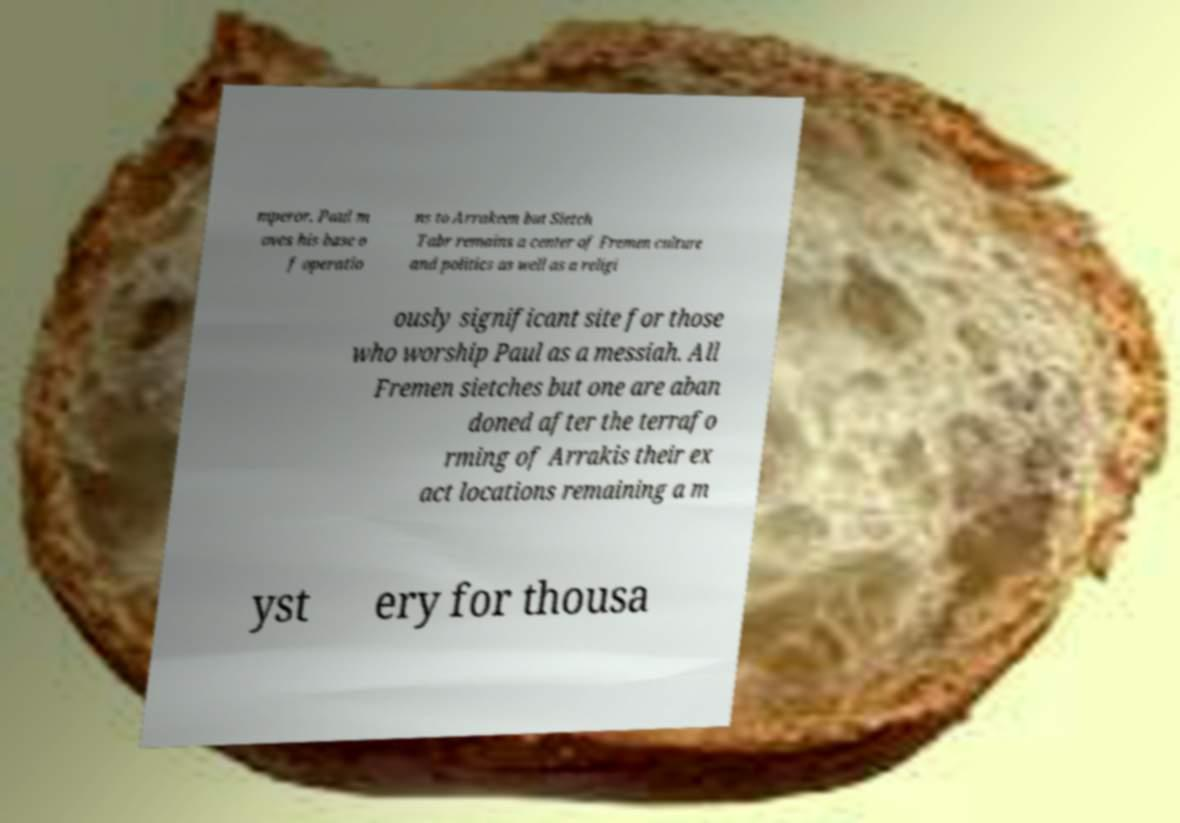Could you assist in decoding the text presented in this image and type it out clearly? mperor. Paul m oves his base o f operatio ns to Arrakeen but Sietch Tabr remains a center of Fremen culture and politics as well as a religi ously significant site for those who worship Paul as a messiah. All Fremen sietches but one are aban doned after the terrafo rming of Arrakis their ex act locations remaining a m yst ery for thousa 